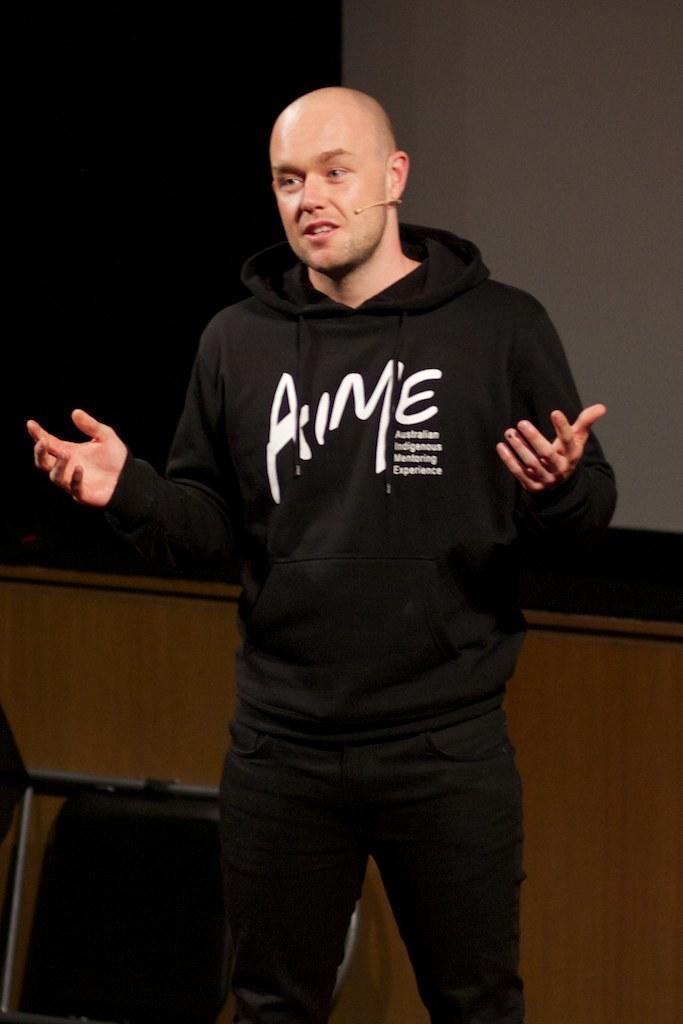In one or two sentences, can you explain what this image depicts? In the picture there is a man he is wearing black dress and he is speaking something, behind the man there is a wall and black surface beside the wall. 